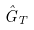<formula> <loc_0><loc_0><loc_500><loc_500>\hat { G } _ { T }</formula> 